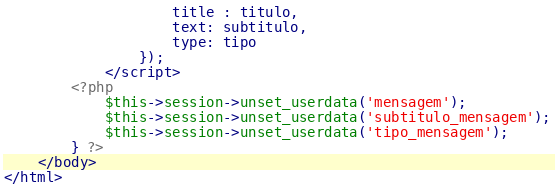<code> <loc_0><loc_0><loc_500><loc_500><_PHP_>					title : titulo,
					text: subtitulo,
					type: tipo
				});
			</script>
		<?php 
			$this->session->unset_userdata('mensagem');
			$this->session->unset_userdata('subtitulo_mensagem');
			$this->session->unset_userdata('tipo_mensagem');
		} ?>
	</body>
</html></code> 